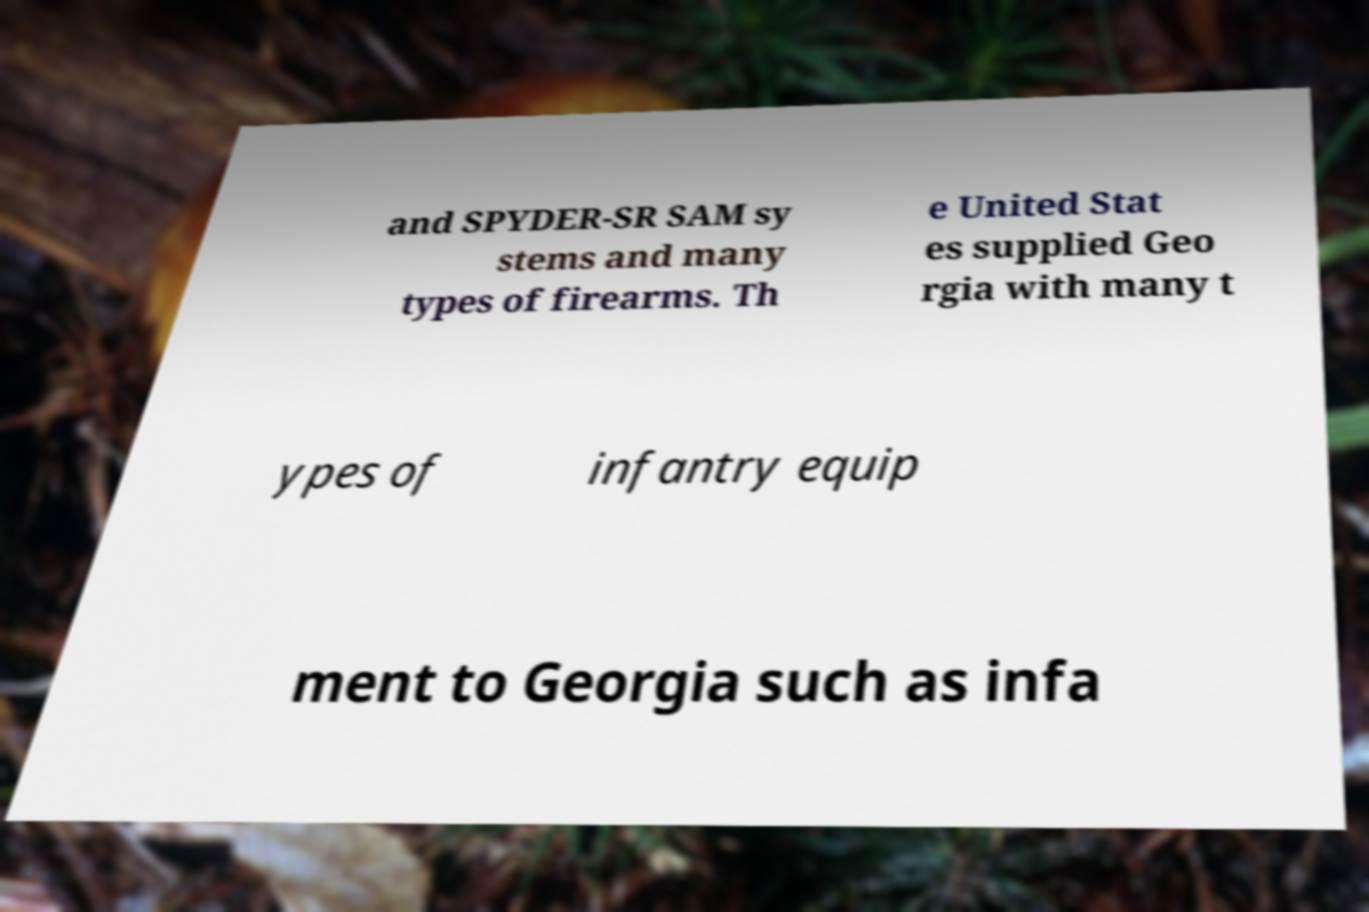For documentation purposes, I need the text within this image transcribed. Could you provide that? and SPYDER-SR SAM sy stems and many types of firearms. Th e United Stat es supplied Geo rgia with many t ypes of infantry equip ment to Georgia such as infa 